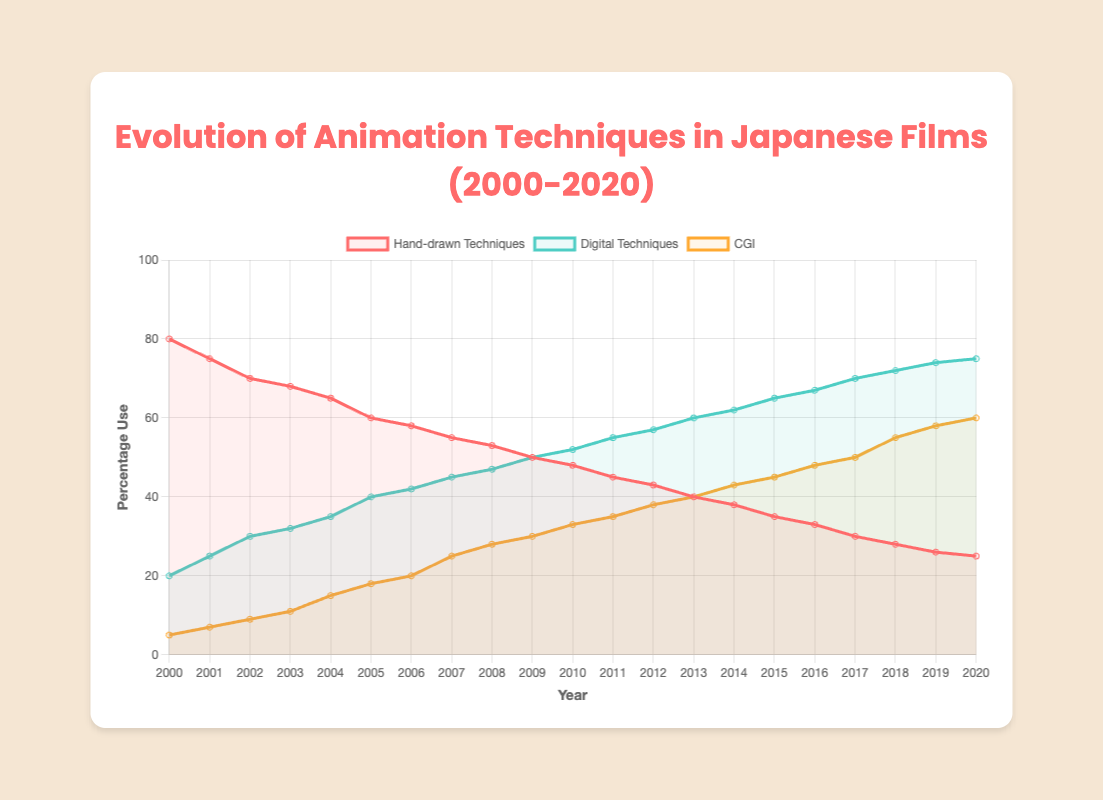What was the overall trend in the use of hand-drawn animation techniques from 2000 to 2020? The overall trend in the use of hand-drawn animation techniques shows a steady decline from 80% in 2000 to 25% in 2020.
Answer: Declining In which year did digital techniques surpass hand-drawn techniques in terms of usage percentage for the first time? To find this, compare the percentages of digital techniques and hand-drawn techniques for each year. In 2009, both techniques are used equally at 50%. In 2010, digital techniques exceed hand-drawn techniques (52% vs 48%).
Answer: 2010 How much did the CGI use percentage increase from 2000 to 2020? Subtract the CGI use percentage in 2000 from the CGI use percentage in 2020: (60% - 5%). This represents an overall increase of 55 percentage points.
Answer: 55% Which year had the highest combined percentage of digital techniques and CGI, and what was the combined percentage? Find the sum of digital techniques and CGI for each year. The year 2020 had the highest combined percentage: 75% (digital) + 60% (CGI) = 135%.
Answer: 2020, 135% By how much did the use percentage of digital techniques change from 2000 to 2010? Subtract the digital techniques use percentage in 2000 from the percentage in 2010: (52% - 20%). This is an increase of 32 percentage points.
Answer: 32% Compare the use of hand-drawn techniques and CGI in 2005. How many times more was hand-drawn techniques used compared to CGI? Divide the hand-drawn percentage by the CGI percentage for 2005: 60% / 18% ≈ 3.33 times.
Answer: 3.33 times What is the average use percentage of hand-drawn techniques from 2000 to 2020? Add up the hand-drawn use percentages for each year and divide by the number of years (21): (80+75+70+68+65+60+58+55+53+50+48+45+43+40+38+35+33+30+28+26+25)/21 ≈ 50.95%.
Answer: 50.95% Which animation technique saw the largest percentage increase from 2000 to 2020? Calculate the percentage increase for each technique: Hand-drawn (-55%), Digital (+55%), CGI (+55%). Both CGI and Digital saw equal increases, but CGI started from a lower base.
Answer: CGI and Digital How did the use of CGI change between 2008 and 2018? Subtract the percentage of CGI in 2008 from the percentage in 2018: 55% - 28% = 27%. CGI use increased by 27 percentage points.
Answer: Increased by 27% In what year did the hand-drawn technique usage fall below 50% for the first time? Look for the first year where the hand-drawn usage is below 50%. It occurs in 2009 when the hand-drawn technique usage is at 50%.
Answer: 2009 